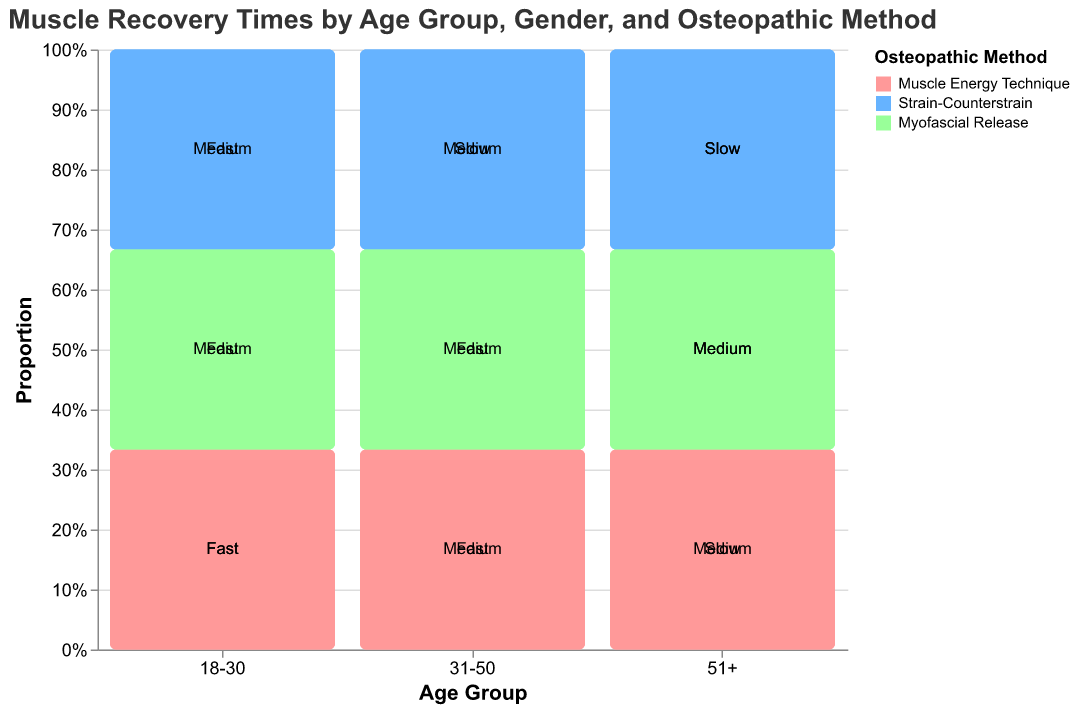Which age group recovers the fastest overall? To determine the age group that recovers the fastest, look at the proportions of "Fast" recovery times across different age groups for both genders. The 18-30 age group shows the highest proportion of "Fast" recovery times.
Answer: 18-30 How does the recovery time for females aged 31-50 compare when using Myofascial Release and Muscle Energy Technique? In the figure for females aged 31-50, Myofascial Release shows a "Fast" recovery time, and Muscle Energy Technique also shows a "Fast" recovery time.
Answer: Both have "Fast" recovery times Which osteopathic method is most effective for males aged 18-30? Examine the recovery time labels for males aged 18-30. Muscle Energy Technique and Myofascial Release both show "Fast" recovery times, while Strain-Counterstrain shows "Medium".
Answer: Muscle Energy Technique and Myofascial Release Is there any method that results in a "Slow" recovery time for females aged 18-30? In the mosaic plot, for females aged 18-30 in all methods, neither Muscle Energy Technique, Strain-Counterstrain, nor Myofascial Release shows a "Slow" recovery time.
Answer: No What method appears to work less effectively for men over 51? Look at the recovery time labels for males aged 51+ in the figure. Both Muscle Energy Technique and Strain-Counterstrain show "Slow" recovery times, while Myofascial Release shows "Medium".
Answer: Muscle Energy Technique and Strain-Counterstrain How do recovery times differ between males and females aged 31-50 using Strain-Counterstrain? For males aged 31-50, Strain-Counterstrain shows a "Slow" recovery time, while for females aged 31-50, it shows a "Medium" recovery time.
Answer: Males - "Slow", Females - "Medium" Which gender shows a better recovery rate using Myofascial Release in the 18-30 age group? For Myofascial Release in the 18-30 age group, males show "Fast" recovery time while females show "Medium" recovery time.
Answer: Males In the 51+ age group, which method has the least effective recovery time for both genders? For the 51+ age group, both Muscles Energy Technique and Strain-Counterstrain show "Slow" recovery times for both males and females.
Answer: Muscle Energy Technique and Strain-Counterstrain Across all age groups and genders, which method appears more consistently effective? Check the consistency of "Fast" and "Medium" recovery times across all age groups and genders in the mosaic plot. Myofascial Release shows more consistently positive recovery times compared to other methods.
Answer: Myofascial Release 